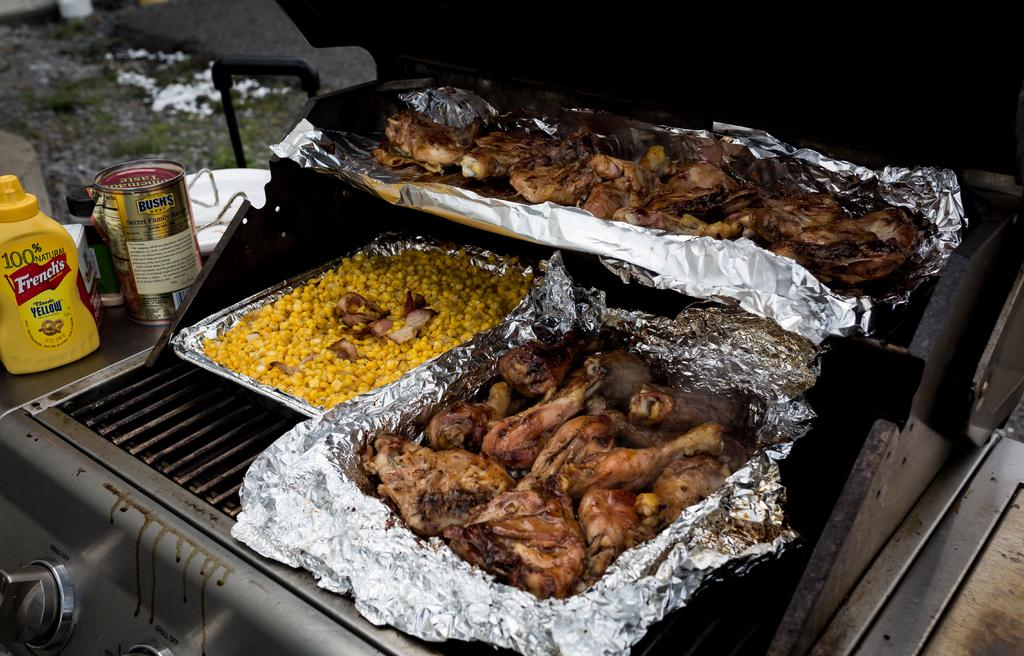<image>
Write a terse but informative summary of the picture. A bottle of French's mustard sits to the side of the grill which is full of chicken and corn. 